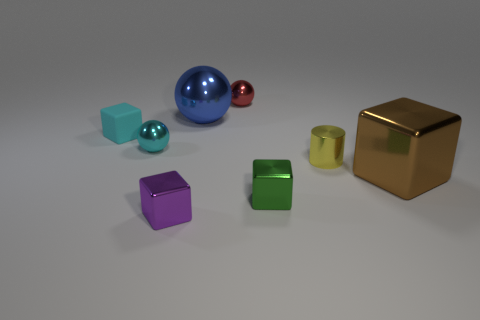Subtract all tiny spheres. How many spheres are left? 1 Add 1 red metallic spheres. How many objects exist? 9 Subtract all cyan spheres. How many spheres are left? 2 Subtract all balls. How many objects are left? 5 Add 6 small green metallic objects. How many small green metallic objects exist? 7 Subtract 1 green blocks. How many objects are left? 7 Subtract all cyan cylinders. Subtract all red spheres. How many cylinders are left? 1 Subtract all brown spheres. How many brown blocks are left? 1 Subtract all tiny cyan shiny blocks. Subtract all brown metal objects. How many objects are left? 7 Add 5 small cyan matte blocks. How many small cyan matte blocks are left? 6 